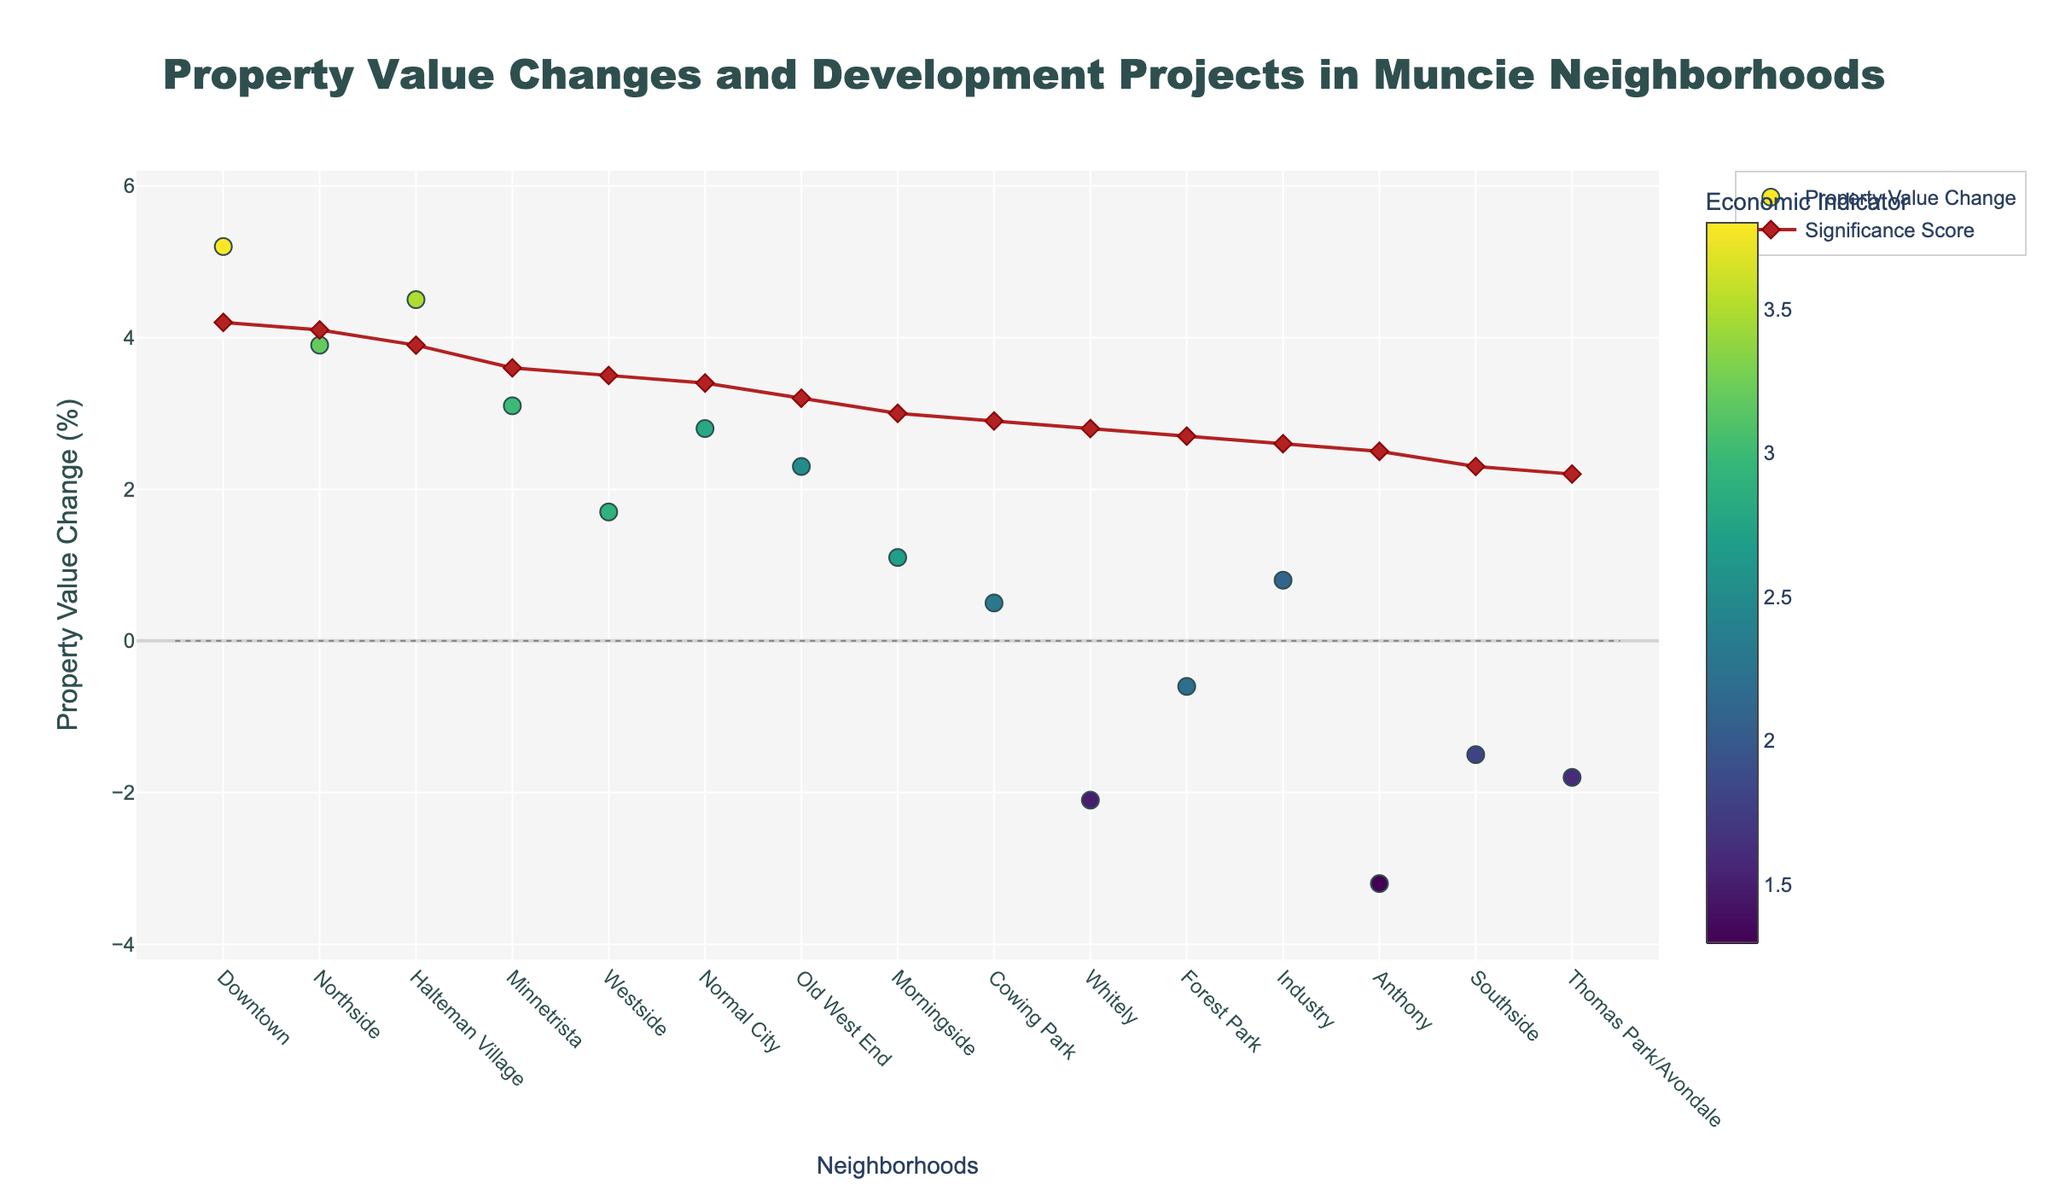What is the title of the plot? The title is displayed at the top center of the figure. It is written in a larger font and is almost always the most prominent text.
Answer: Property Value Changes and Development Projects in Muncie Neighborhoods Which neighborhood experienced the highest increase in property values? Locate the highest point on the y-axis labeled "Property Value Change (%)", then identify the corresponding neighborhood on the x-axis.
Answer: Downtown What does the color of the markers represent? Refer to the color bar on the right side of the plot, which is titled "Economic Indicator". The color of the markers correspond to values of this indicator.
Answer: Economic Indicator How many neighborhoods show a negative change in property values? Identify the number of markers that are below the zero line on the y-axis labeled "Property Value Change (%)", which signifies negative values.
Answer: 4 Which development project is associated with the highest significance score? Locate the highest point on the "Significance Score" line and identify its corresponding neighborhood on the x-axis, then check the hover text for the development project.
Answer: Riverfront Revitalization What is the average property value change for neighborhoods with a significance score above 3? Identify neighborhoods with a significance score above 3 by looking at the markers on the secondary plot line, extract their property value changes, and calculate the average of those values.
Answer: (5.2 + 1.7 + 3.9 + 4.5 + 3.1 + 2.8) / 6 = 3.53 Which neighborhood with an economic indicator above 3 has the lowest property value change? First, identify the neighborhoods where the marker color is above 3, then find the lowest point among those neighborhoods on the y-axis labeled "Property Value Change (%)".
Answer: Westside Compare the property value changes between Southside and Northside. Which one has a higher value? Check the positions of Southside and Northside on the y-axis labeled "Property Value Change (%)" and compare their values.
Answer: Northside For neighborhoods with a negative property value change, which one has the highest economic indicator? Identify the markers below zero on the y-axis labeled "Property Value Change (%)", compare their colors (representing the economic indicator), and find the one with the highest value.
Answer: Forest Park What is the significance score for Halteman Village, and how does it compare to the average significance score of all neighborhoods? Find Halteman Village on the significance score line, then calculate the average significance score for all neighborhoods by summing their scores and dividing by the number of neighborhoods. Compare Halteman Village's score to this average.
Answer: 4.5 vs. average 3.1 (4.2 + 2.8 + 3.5 + 4.1 + 2.6 + 2.3 + 3.2 + 2.7 + 3.0 + 2.5 + 3.9 + 3.6 + 3.4 + 2.2 + 2.9) / 15 